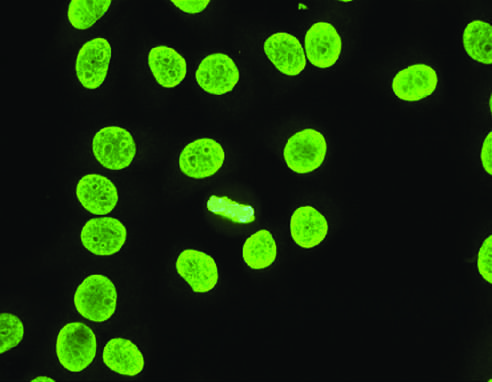re skin stem cells typical of antibodies reactive with dsdna, nucleosomes, and histones, and common in sle?
Answer the question using a single word or phrase. No 